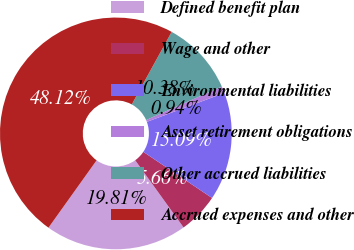Convert chart. <chart><loc_0><loc_0><loc_500><loc_500><pie_chart><fcel>Defined benefit plan<fcel>Wage and other<fcel>Environmental liabilities<fcel>Asset retirement obligations<fcel>Other accrued liabilities<fcel>Accrued expenses and other<nl><fcel>19.81%<fcel>5.66%<fcel>15.09%<fcel>0.94%<fcel>10.38%<fcel>48.12%<nl></chart> 